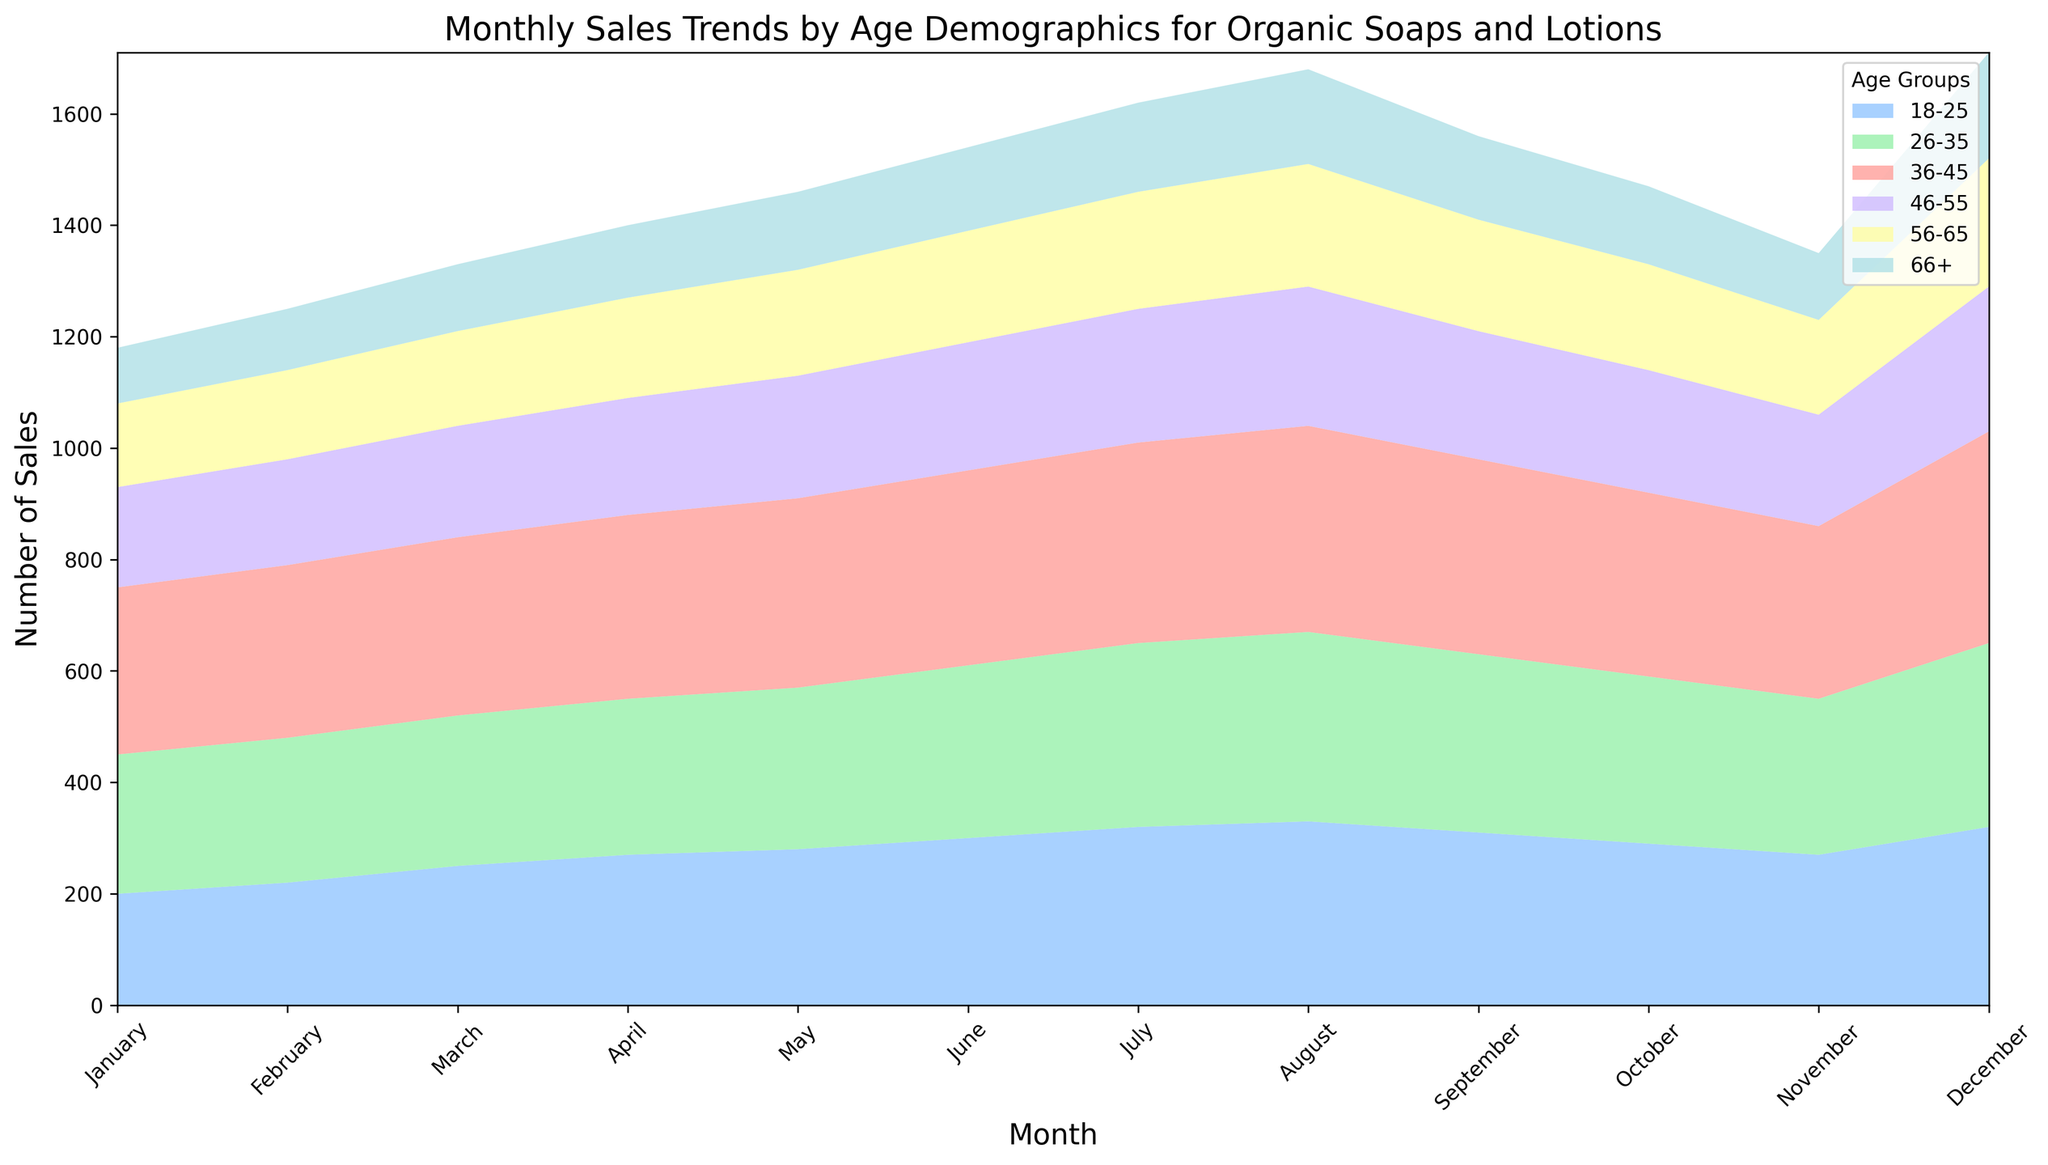Which age group had the highest sales in December? Look at the December section of the chart and identify the age group with the tallest area. The 'age_36_45' group has the highest value.
Answer: 36-45 Which month had the lowest sales for the age group 66+? Observe the monthly trends for the '66+' group and identify the shortest area segment. January has the lowest sales for this group.
Answer: January Compare the sales trends of the 18-25 and 56-65 age groups. Which group had more consistent sales across the months? Look at the visual flow of the areas for both '18-25' and '56-65'. The '56-65' age group has a more stable and flatter trend compared to the '18-25' group, which fluctuates.
Answer: 56-65 What is the total number of sales for the '26-35' age group in the first quarter (January-March)? Sum the sales of the '26-35' age group for January (250), February (260), and March (270). The total is 250 + 260 + 270 = 780.
Answer: 780 In which month did the '46-55' age group see its highest sales? Check the height of the area corresponding to the '46-55' age group in each month. December shows the highest sales for this group.
Answer: December By how much did sales for the '18-25' age group increase from January to December? Find the difference between the sales in December (320) and January (200) for the '18-25' age group. The increase is 320 - 200 = 120.
Answer: 120 Which two age groups showed an equal number of sales in September? Look at the September portion of the graph and identify overlapping height segments. The '56-65' and '66+' age groups both have sales of 150.
Answer: 56-65 and 66+ Is there a month where all age groups saw a rise in sales compared to the previous month? Analyze the sales trend linearly across each month for rising trends. June shows an increase in sales across all age groups compared to May.
Answer: June 